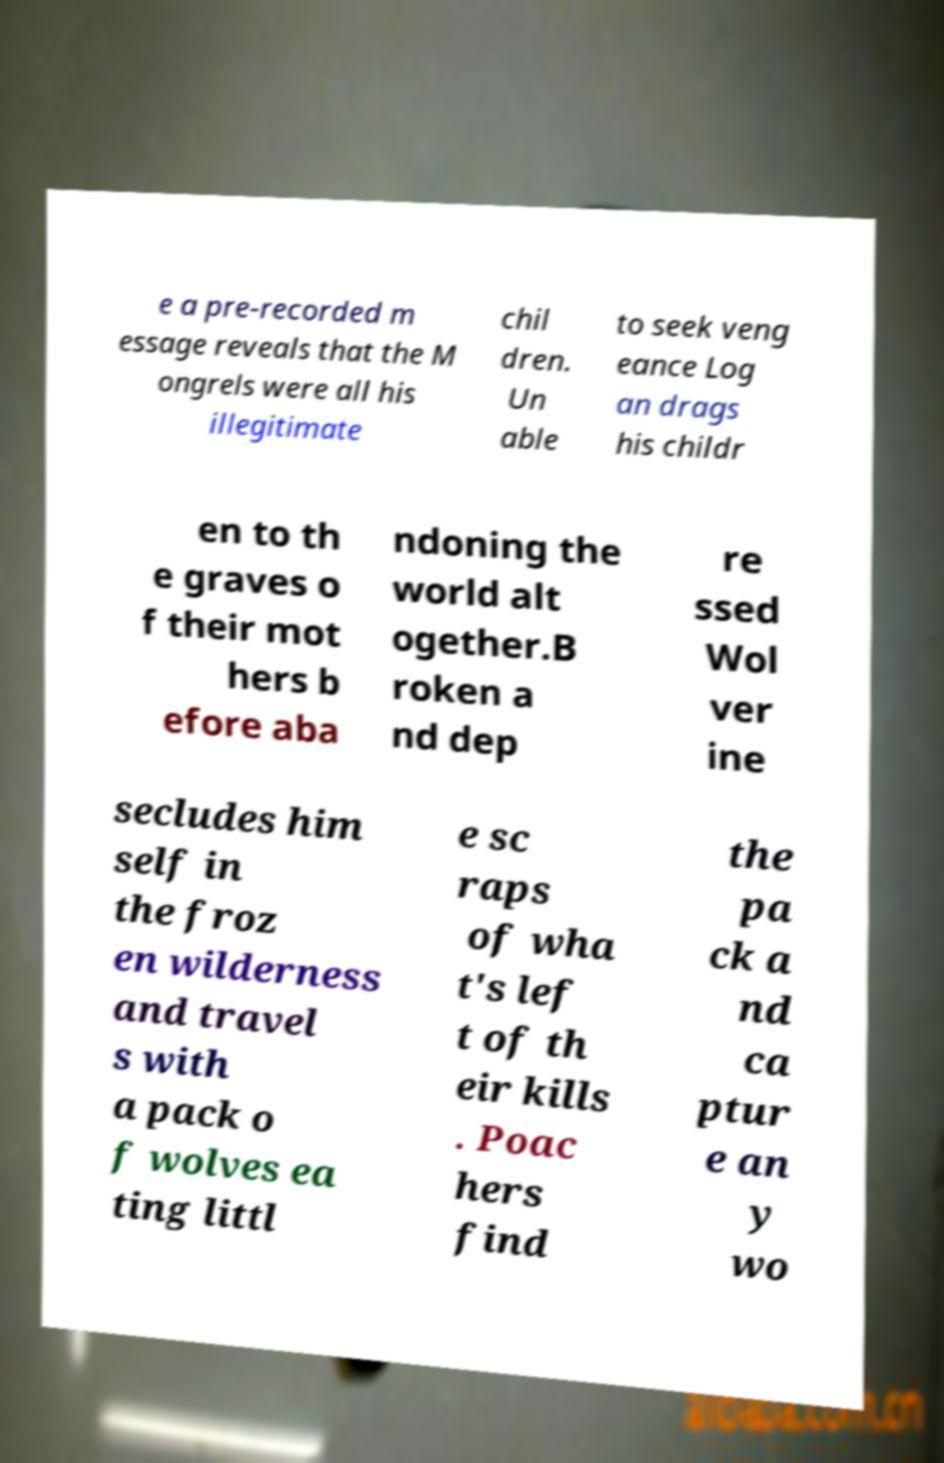For documentation purposes, I need the text within this image transcribed. Could you provide that? e a pre-recorded m essage reveals that the M ongrels were all his illegitimate chil dren. Un able to seek veng eance Log an drags his childr en to th e graves o f their mot hers b efore aba ndoning the world alt ogether.B roken a nd dep re ssed Wol ver ine secludes him self in the froz en wilderness and travel s with a pack o f wolves ea ting littl e sc raps of wha t's lef t of th eir kills . Poac hers find the pa ck a nd ca ptur e an y wo 